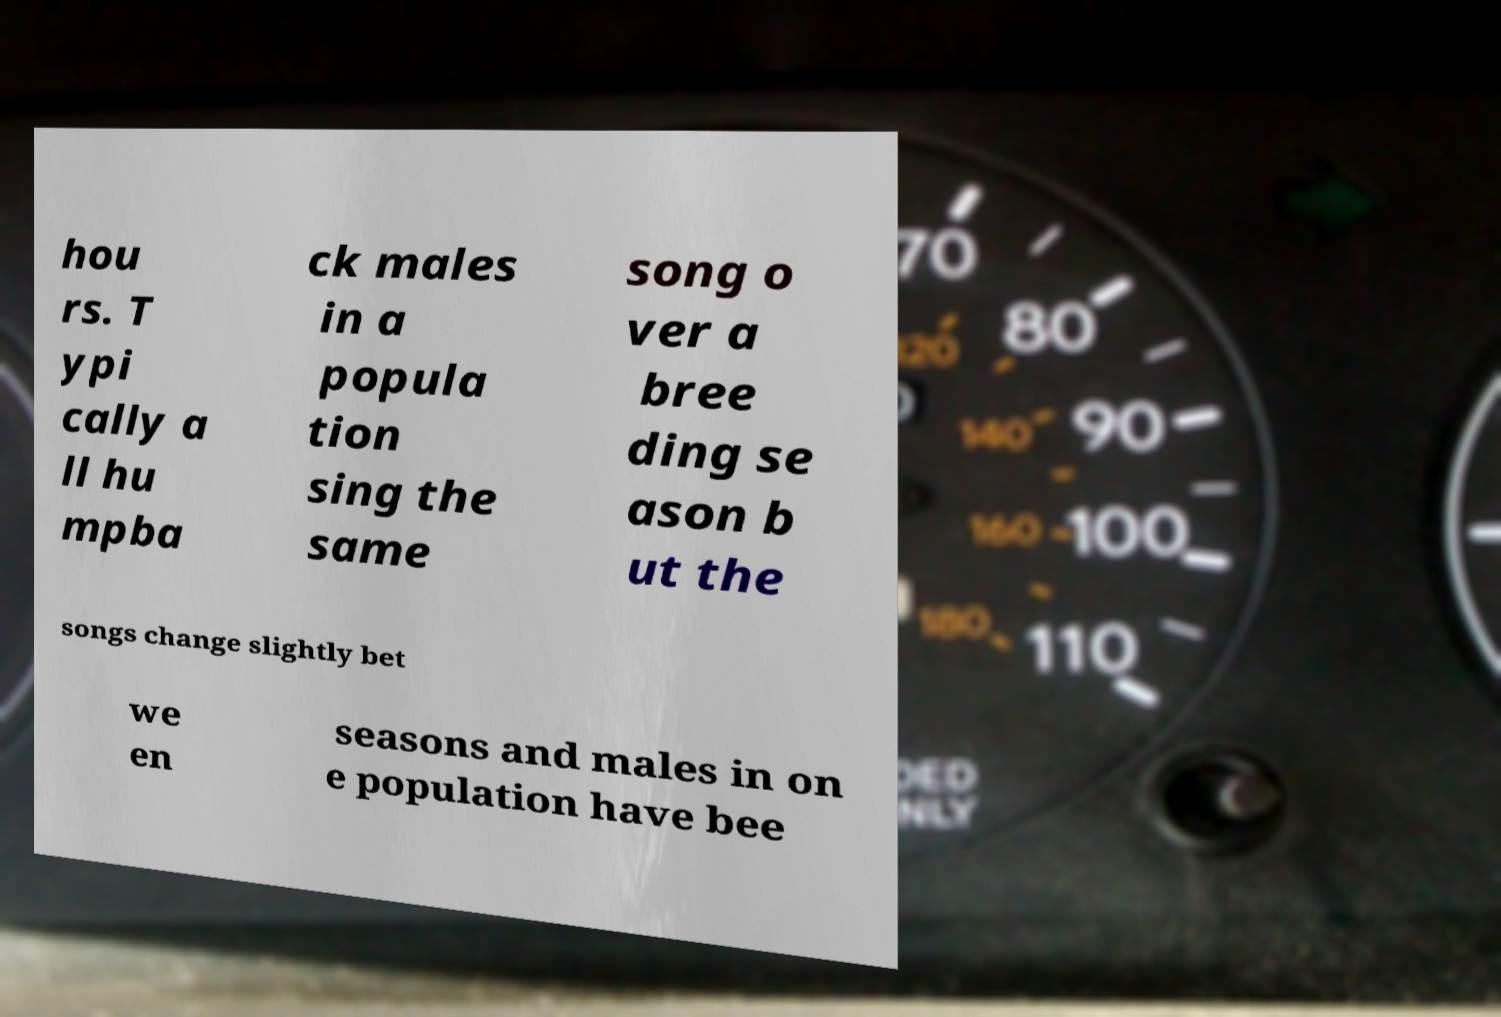Can you accurately transcribe the text from the provided image for me? hou rs. T ypi cally a ll hu mpba ck males in a popula tion sing the same song o ver a bree ding se ason b ut the songs change slightly bet we en seasons and males in on e population have bee 